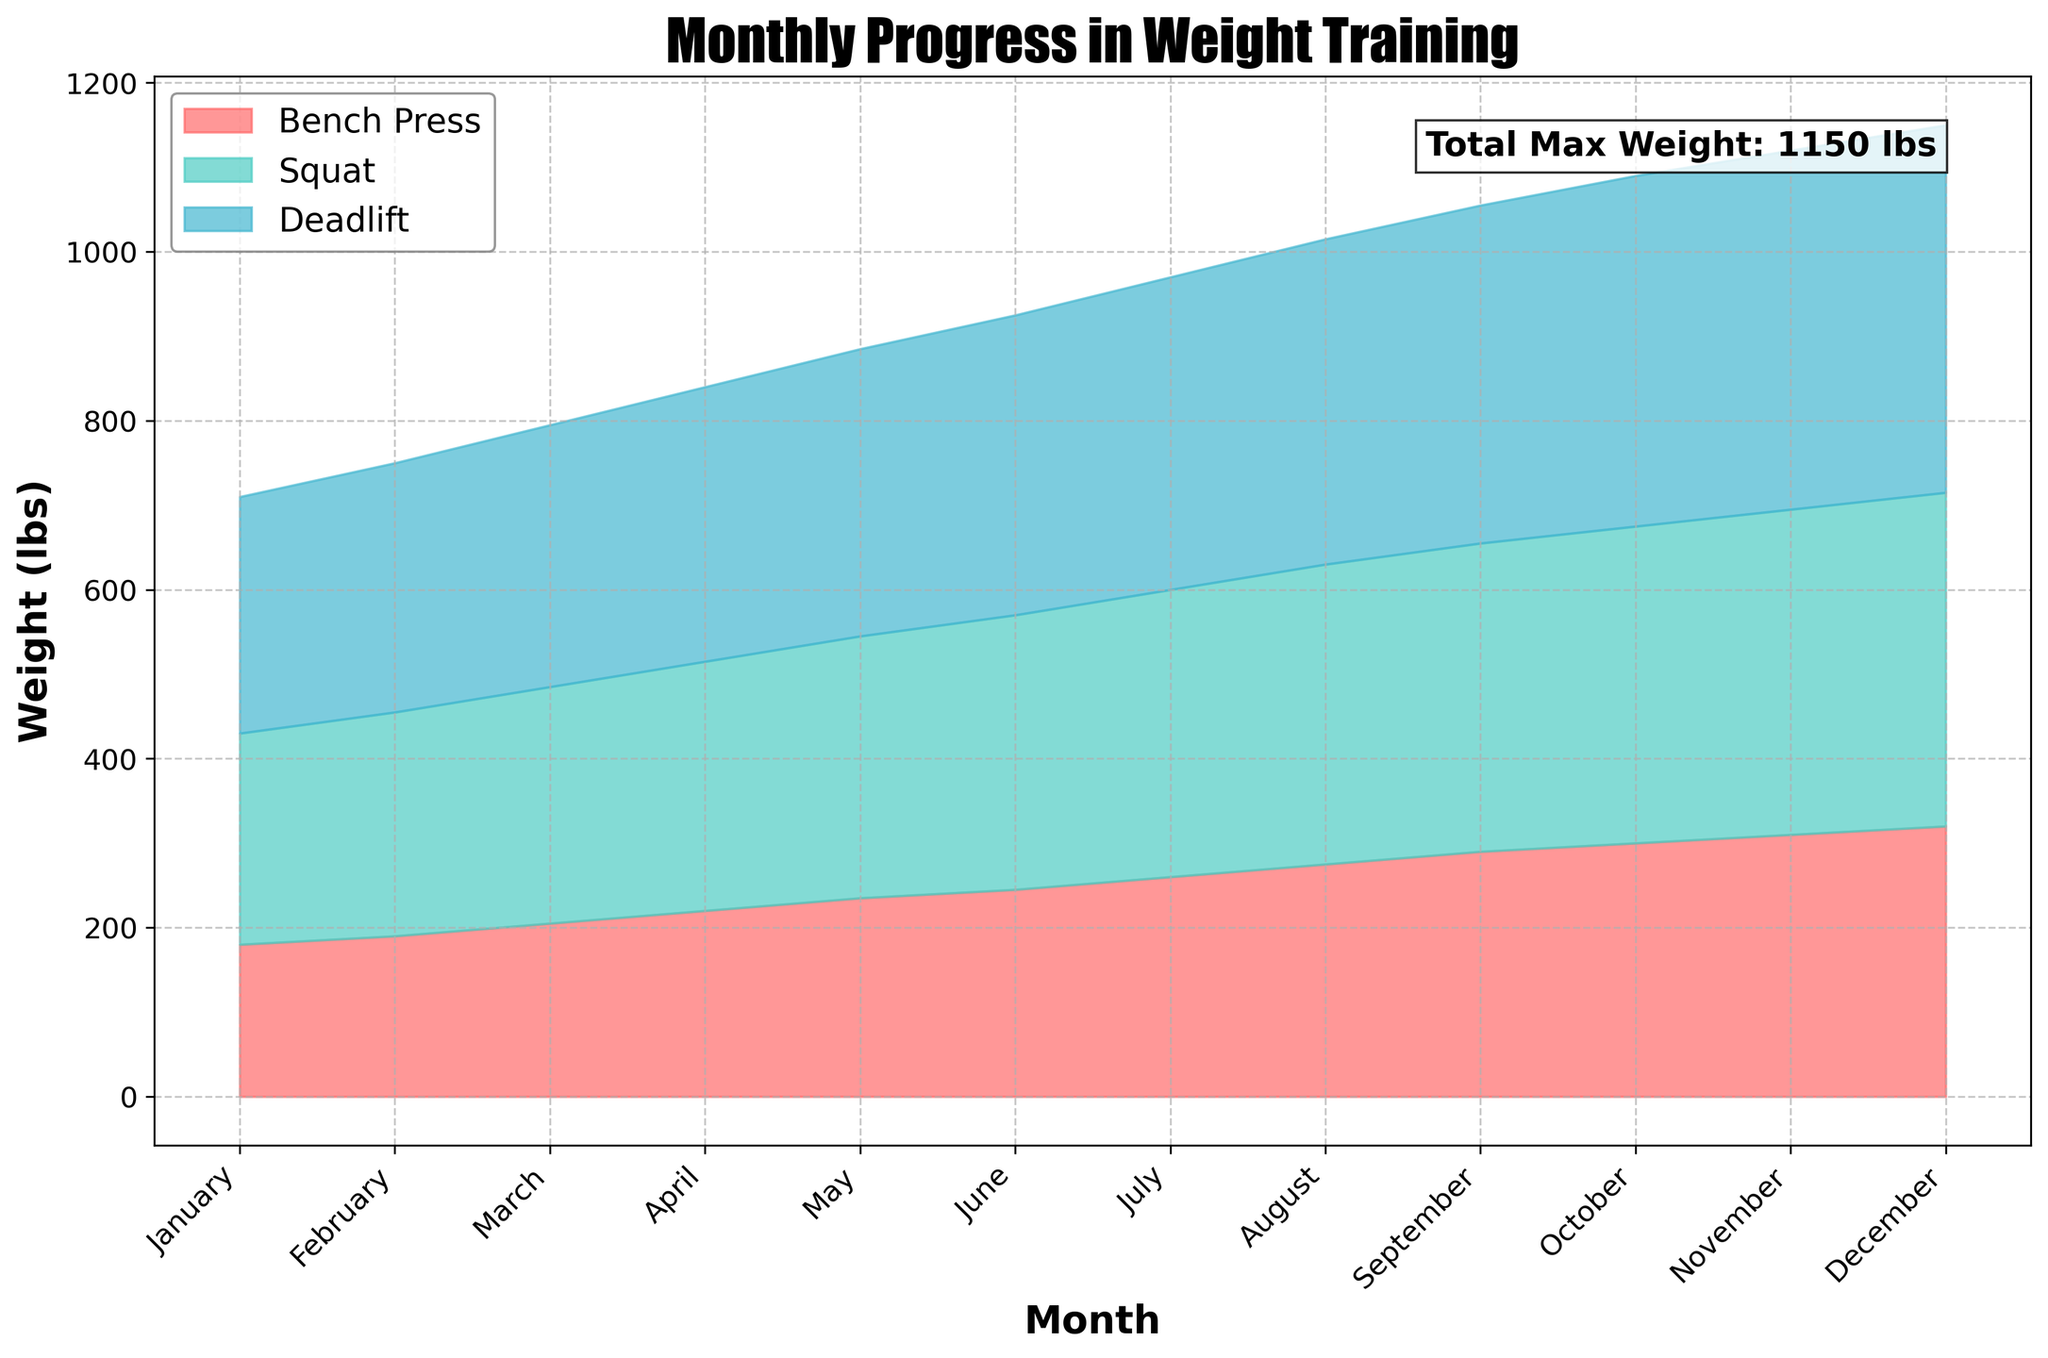What is the title of the area chart? The title is prominently displayed at the top of the figure, summarizing what the chart is about.
Answer: Monthly Progress in Weight Training What are the three types of exercises shown in the figure? The labels in the legend indicate the three different exercises displayed in the chart.
Answer: Bench Press, Squat, Deadlift How much did the max deadlift increase from January to December? The values for deadlift max in January and December can be subtracted to find the increase. January has 280 lbs, and December has 435 lbs. The difference is 435 - 280.
Answer: 155 lbs Which month shows the highest overall weight lift? You can observe the height of the combined area for bench press, squat, and deadlift across months. December has the highest overall height.
Answer: December How much was the total max weight in April? Add the max weights for bench press, squat, and deadlift for April. Bench Press: 220 lbs, Squat: 295 lbs, Deadlift: 325 lbs. The total is 220 + 295 + 325.
Answer: 840 lbs How does the max bench press weight in July compare to September? Compare the values of the bench press for July and September. July has 260 lbs, September has 290 lbs.
Answer: 30 lbs less in July What's the trend in max squat weight over the year? The max squat weight progressively increases from January (250 lbs) to December (395 lbs). This indicates a steady upward trend.
Answer: Steadily increasing In which month do the increases in max squat weight seem to slow down? Analyze the differences in monthly increases for squat max. The sharp increases slow down around October to November.
Answer: October to November What is the smallest monthly increase in bench press max weight? To find the smallest increase, calculate the monthly differences and spot the smallest. The differences range around 10 to 15 lbs, with the smallest increase being 10 lbs (June to July).
Answer: 10 lbs If you add the max lifts for March, what's the average of these exercises? For March: Bench Press (205 lbs), Squat (280 lbs), Deadlift (310 lbs). First, sum the amounts: 205 + 280 + 310 = 795 lbs. Then, divide by 3 to find the average.
Answer: 265 lbs 